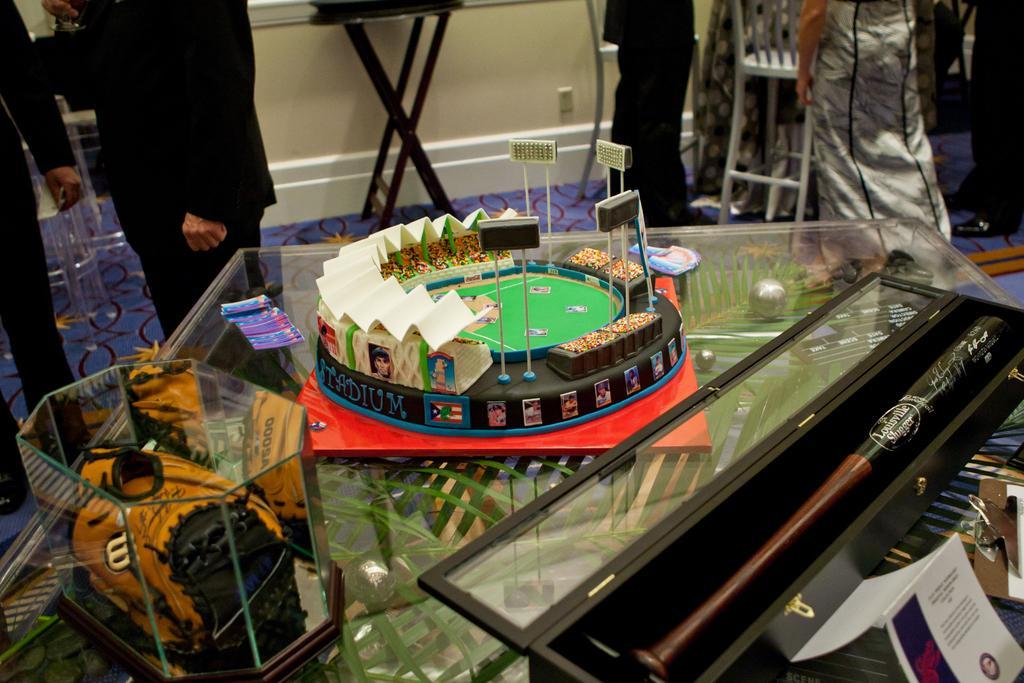How would you summarize this image in a sentence or two? There is a glass table which has some objects on it and there are some persons standing in the background 